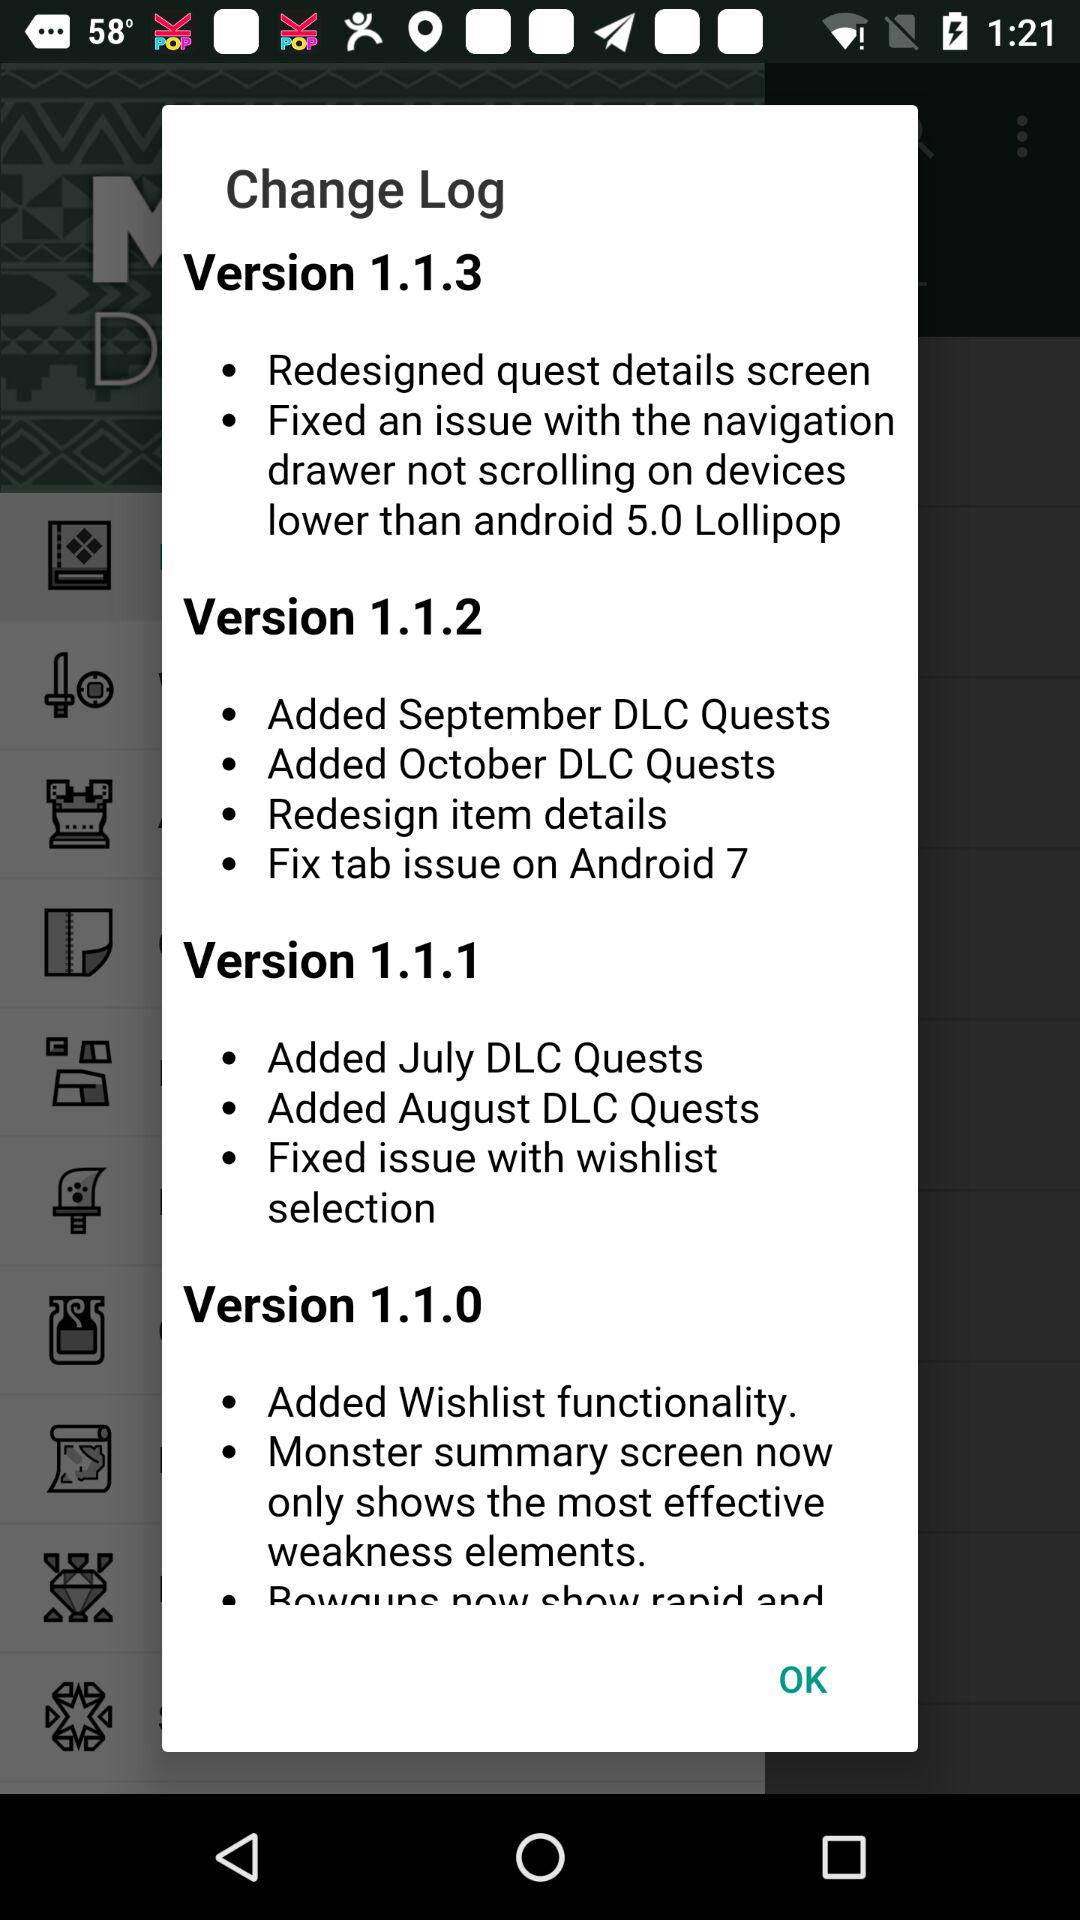What makes Version 1.1.0 so special?
When the provided information is insufficient, respond with <no answer>. <no answer> 